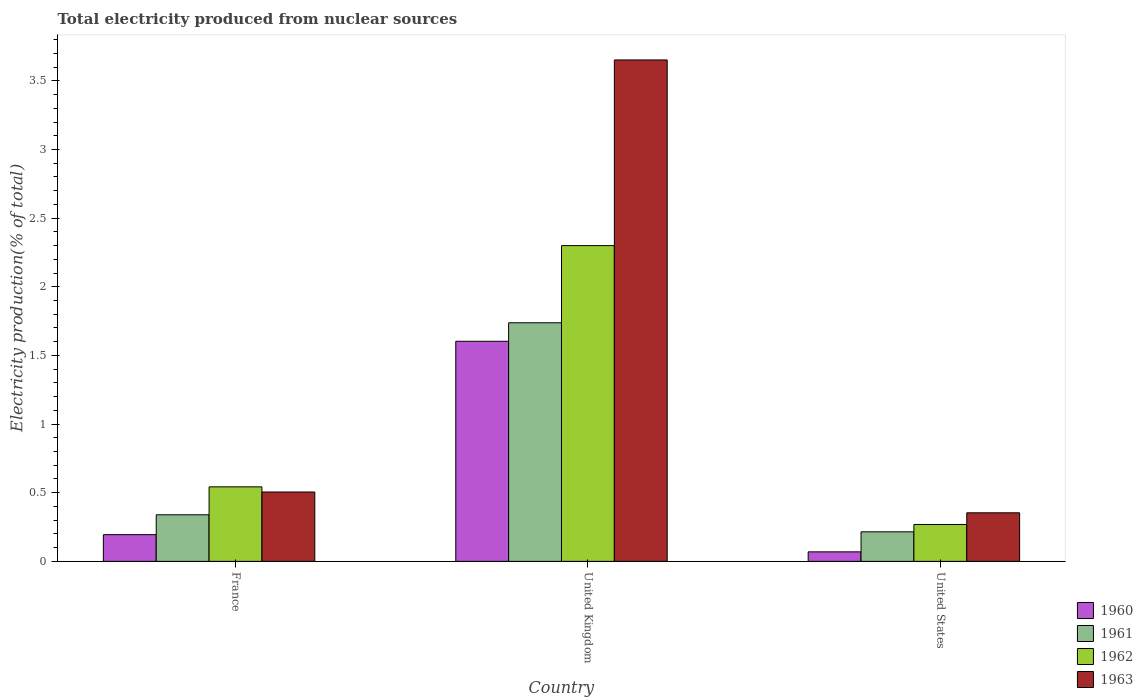How many different coloured bars are there?
Offer a very short reply. 4. How many groups of bars are there?
Your answer should be compact. 3. How many bars are there on the 3rd tick from the left?
Make the answer very short. 4. How many bars are there on the 3rd tick from the right?
Provide a succinct answer. 4. What is the label of the 3rd group of bars from the left?
Ensure brevity in your answer.  United States. In how many cases, is the number of bars for a given country not equal to the number of legend labels?
Provide a succinct answer. 0. What is the total electricity produced in 1963 in United States?
Your answer should be very brief. 0.35. Across all countries, what is the maximum total electricity produced in 1960?
Ensure brevity in your answer.  1.6. Across all countries, what is the minimum total electricity produced in 1962?
Your response must be concise. 0.27. In which country was the total electricity produced in 1962 maximum?
Ensure brevity in your answer.  United Kingdom. What is the total total electricity produced in 1961 in the graph?
Your answer should be very brief. 2.29. What is the difference between the total electricity produced in 1963 in United Kingdom and that in United States?
Your response must be concise. 3.3. What is the difference between the total electricity produced in 1962 in United Kingdom and the total electricity produced in 1961 in United States?
Keep it short and to the point. 2.08. What is the average total electricity produced in 1961 per country?
Your answer should be very brief. 0.76. What is the difference between the total electricity produced of/in 1961 and total electricity produced of/in 1960 in France?
Make the answer very short. 0.14. What is the ratio of the total electricity produced in 1960 in United Kingdom to that in United States?
Provide a short and direct response. 23.14. What is the difference between the highest and the second highest total electricity produced in 1962?
Offer a terse response. 0.27. What is the difference between the highest and the lowest total electricity produced in 1960?
Keep it short and to the point. 1.53. Is the sum of the total electricity produced in 1962 in France and United States greater than the maximum total electricity produced in 1961 across all countries?
Ensure brevity in your answer.  No. What does the 1st bar from the left in France represents?
Provide a short and direct response. 1960. Is it the case that in every country, the sum of the total electricity produced in 1962 and total electricity produced in 1960 is greater than the total electricity produced in 1963?
Ensure brevity in your answer.  No. How many bars are there?
Make the answer very short. 12. Are all the bars in the graph horizontal?
Provide a succinct answer. No. How many countries are there in the graph?
Ensure brevity in your answer.  3. What is the difference between two consecutive major ticks on the Y-axis?
Keep it short and to the point. 0.5. Are the values on the major ticks of Y-axis written in scientific E-notation?
Offer a terse response. No. Does the graph contain any zero values?
Give a very brief answer. No. Where does the legend appear in the graph?
Your answer should be compact. Bottom right. How are the legend labels stacked?
Provide a short and direct response. Vertical. What is the title of the graph?
Your answer should be very brief. Total electricity produced from nuclear sources. What is the Electricity production(% of total) in 1960 in France?
Provide a short and direct response. 0.19. What is the Electricity production(% of total) of 1961 in France?
Make the answer very short. 0.34. What is the Electricity production(% of total) in 1962 in France?
Give a very brief answer. 0.54. What is the Electricity production(% of total) in 1963 in France?
Provide a short and direct response. 0.51. What is the Electricity production(% of total) of 1960 in United Kingdom?
Offer a terse response. 1.6. What is the Electricity production(% of total) in 1961 in United Kingdom?
Provide a succinct answer. 1.74. What is the Electricity production(% of total) in 1962 in United Kingdom?
Your answer should be compact. 2.3. What is the Electricity production(% of total) in 1963 in United Kingdom?
Offer a terse response. 3.65. What is the Electricity production(% of total) of 1960 in United States?
Provide a short and direct response. 0.07. What is the Electricity production(% of total) in 1961 in United States?
Offer a terse response. 0.22. What is the Electricity production(% of total) of 1962 in United States?
Your answer should be very brief. 0.27. What is the Electricity production(% of total) in 1963 in United States?
Offer a very short reply. 0.35. Across all countries, what is the maximum Electricity production(% of total) in 1960?
Your answer should be compact. 1.6. Across all countries, what is the maximum Electricity production(% of total) of 1961?
Offer a very short reply. 1.74. Across all countries, what is the maximum Electricity production(% of total) of 1962?
Provide a short and direct response. 2.3. Across all countries, what is the maximum Electricity production(% of total) of 1963?
Give a very brief answer. 3.65. Across all countries, what is the minimum Electricity production(% of total) in 1960?
Make the answer very short. 0.07. Across all countries, what is the minimum Electricity production(% of total) of 1961?
Make the answer very short. 0.22. Across all countries, what is the minimum Electricity production(% of total) in 1962?
Your answer should be compact. 0.27. Across all countries, what is the minimum Electricity production(% of total) in 1963?
Your response must be concise. 0.35. What is the total Electricity production(% of total) of 1960 in the graph?
Your response must be concise. 1.87. What is the total Electricity production(% of total) of 1961 in the graph?
Your answer should be compact. 2.29. What is the total Electricity production(% of total) of 1962 in the graph?
Keep it short and to the point. 3.11. What is the total Electricity production(% of total) in 1963 in the graph?
Your answer should be very brief. 4.51. What is the difference between the Electricity production(% of total) in 1960 in France and that in United Kingdom?
Make the answer very short. -1.41. What is the difference between the Electricity production(% of total) of 1961 in France and that in United Kingdom?
Provide a short and direct response. -1.4. What is the difference between the Electricity production(% of total) in 1962 in France and that in United Kingdom?
Provide a succinct answer. -1.76. What is the difference between the Electricity production(% of total) of 1963 in France and that in United Kingdom?
Offer a very short reply. -3.15. What is the difference between the Electricity production(% of total) in 1960 in France and that in United States?
Make the answer very short. 0.13. What is the difference between the Electricity production(% of total) in 1961 in France and that in United States?
Offer a terse response. 0.12. What is the difference between the Electricity production(% of total) in 1962 in France and that in United States?
Your response must be concise. 0.27. What is the difference between the Electricity production(% of total) in 1963 in France and that in United States?
Ensure brevity in your answer.  0.15. What is the difference between the Electricity production(% of total) of 1960 in United Kingdom and that in United States?
Keep it short and to the point. 1.53. What is the difference between the Electricity production(% of total) of 1961 in United Kingdom and that in United States?
Your answer should be compact. 1.52. What is the difference between the Electricity production(% of total) in 1962 in United Kingdom and that in United States?
Your answer should be compact. 2.03. What is the difference between the Electricity production(% of total) in 1963 in United Kingdom and that in United States?
Your answer should be very brief. 3.3. What is the difference between the Electricity production(% of total) in 1960 in France and the Electricity production(% of total) in 1961 in United Kingdom?
Offer a terse response. -1.54. What is the difference between the Electricity production(% of total) in 1960 in France and the Electricity production(% of total) in 1962 in United Kingdom?
Give a very brief answer. -2.11. What is the difference between the Electricity production(% of total) of 1960 in France and the Electricity production(% of total) of 1963 in United Kingdom?
Provide a succinct answer. -3.46. What is the difference between the Electricity production(% of total) of 1961 in France and the Electricity production(% of total) of 1962 in United Kingdom?
Provide a succinct answer. -1.96. What is the difference between the Electricity production(% of total) of 1961 in France and the Electricity production(% of total) of 1963 in United Kingdom?
Provide a short and direct response. -3.31. What is the difference between the Electricity production(% of total) of 1962 in France and the Electricity production(% of total) of 1963 in United Kingdom?
Make the answer very short. -3.11. What is the difference between the Electricity production(% of total) in 1960 in France and the Electricity production(% of total) in 1961 in United States?
Your answer should be compact. -0.02. What is the difference between the Electricity production(% of total) in 1960 in France and the Electricity production(% of total) in 1962 in United States?
Your response must be concise. -0.07. What is the difference between the Electricity production(% of total) in 1960 in France and the Electricity production(% of total) in 1963 in United States?
Give a very brief answer. -0.16. What is the difference between the Electricity production(% of total) in 1961 in France and the Electricity production(% of total) in 1962 in United States?
Provide a short and direct response. 0.07. What is the difference between the Electricity production(% of total) of 1961 in France and the Electricity production(% of total) of 1963 in United States?
Your answer should be very brief. -0.01. What is the difference between the Electricity production(% of total) of 1962 in France and the Electricity production(% of total) of 1963 in United States?
Your response must be concise. 0.19. What is the difference between the Electricity production(% of total) of 1960 in United Kingdom and the Electricity production(% of total) of 1961 in United States?
Ensure brevity in your answer.  1.39. What is the difference between the Electricity production(% of total) of 1960 in United Kingdom and the Electricity production(% of total) of 1962 in United States?
Your answer should be very brief. 1.33. What is the difference between the Electricity production(% of total) of 1960 in United Kingdom and the Electricity production(% of total) of 1963 in United States?
Ensure brevity in your answer.  1.25. What is the difference between the Electricity production(% of total) of 1961 in United Kingdom and the Electricity production(% of total) of 1962 in United States?
Offer a very short reply. 1.47. What is the difference between the Electricity production(% of total) in 1961 in United Kingdom and the Electricity production(% of total) in 1963 in United States?
Offer a very short reply. 1.38. What is the difference between the Electricity production(% of total) in 1962 in United Kingdom and the Electricity production(% of total) in 1963 in United States?
Your answer should be very brief. 1.95. What is the average Electricity production(% of total) of 1960 per country?
Your response must be concise. 0.62. What is the average Electricity production(% of total) of 1961 per country?
Make the answer very short. 0.76. What is the average Electricity production(% of total) in 1962 per country?
Give a very brief answer. 1.04. What is the average Electricity production(% of total) in 1963 per country?
Provide a succinct answer. 1.5. What is the difference between the Electricity production(% of total) of 1960 and Electricity production(% of total) of 1961 in France?
Provide a succinct answer. -0.14. What is the difference between the Electricity production(% of total) in 1960 and Electricity production(% of total) in 1962 in France?
Keep it short and to the point. -0.35. What is the difference between the Electricity production(% of total) in 1960 and Electricity production(% of total) in 1963 in France?
Provide a succinct answer. -0.31. What is the difference between the Electricity production(% of total) of 1961 and Electricity production(% of total) of 1962 in France?
Your answer should be very brief. -0.2. What is the difference between the Electricity production(% of total) in 1961 and Electricity production(% of total) in 1963 in France?
Provide a succinct answer. -0.17. What is the difference between the Electricity production(% of total) of 1962 and Electricity production(% of total) of 1963 in France?
Offer a terse response. 0.04. What is the difference between the Electricity production(% of total) in 1960 and Electricity production(% of total) in 1961 in United Kingdom?
Keep it short and to the point. -0.13. What is the difference between the Electricity production(% of total) of 1960 and Electricity production(% of total) of 1962 in United Kingdom?
Provide a short and direct response. -0.7. What is the difference between the Electricity production(% of total) of 1960 and Electricity production(% of total) of 1963 in United Kingdom?
Your answer should be very brief. -2.05. What is the difference between the Electricity production(% of total) in 1961 and Electricity production(% of total) in 1962 in United Kingdom?
Your answer should be compact. -0.56. What is the difference between the Electricity production(% of total) of 1961 and Electricity production(% of total) of 1963 in United Kingdom?
Your response must be concise. -1.91. What is the difference between the Electricity production(% of total) of 1962 and Electricity production(% of total) of 1963 in United Kingdom?
Keep it short and to the point. -1.35. What is the difference between the Electricity production(% of total) in 1960 and Electricity production(% of total) in 1961 in United States?
Offer a terse response. -0.15. What is the difference between the Electricity production(% of total) of 1960 and Electricity production(% of total) of 1962 in United States?
Your answer should be compact. -0.2. What is the difference between the Electricity production(% of total) of 1960 and Electricity production(% of total) of 1963 in United States?
Your answer should be very brief. -0.28. What is the difference between the Electricity production(% of total) in 1961 and Electricity production(% of total) in 1962 in United States?
Make the answer very short. -0.05. What is the difference between the Electricity production(% of total) in 1961 and Electricity production(% of total) in 1963 in United States?
Your answer should be very brief. -0.14. What is the difference between the Electricity production(% of total) of 1962 and Electricity production(% of total) of 1963 in United States?
Offer a very short reply. -0.09. What is the ratio of the Electricity production(% of total) of 1960 in France to that in United Kingdom?
Give a very brief answer. 0.12. What is the ratio of the Electricity production(% of total) in 1961 in France to that in United Kingdom?
Offer a very short reply. 0.2. What is the ratio of the Electricity production(% of total) in 1962 in France to that in United Kingdom?
Your response must be concise. 0.24. What is the ratio of the Electricity production(% of total) in 1963 in France to that in United Kingdom?
Give a very brief answer. 0.14. What is the ratio of the Electricity production(% of total) of 1960 in France to that in United States?
Provide a succinct answer. 2.81. What is the ratio of the Electricity production(% of total) of 1961 in France to that in United States?
Provide a short and direct response. 1.58. What is the ratio of the Electricity production(% of total) of 1962 in France to that in United States?
Your answer should be very brief. 2.02. What is the ratio of the Electricity production(% of total) of 1963 in France to that in United States?
Provide a succinct answer. 1.43. What is the ratio of the Electricity production(% of total) in 1960 in United Kingdom to that in United States?
Provide a succinct answer. 23.14. What is the ratio of the Electricity production(% of total) in 1961 in United Kingdom to that in United States?
Your response must be concise. 8.08. What is the ratio of the Electricity production(% of total) of 1962 in United Kingdom to that in United States?
Keep it short and to the point. 8.56. What is the ratio of the Electricity production(% of total) in 1963 in United Kingdom to that in United States?
Ensure brevity in your answer.  10.32. What is the difference between the highest and the second highest Electricity production(% of total) in 1960?
Give a very brief answer. 1.41. What is the difference between the highest and the second highest Electricity production(% of total) in 1961?
Give a very brief answer. 1.4. What is the difference between the highest and the second highest Electricity production(% of total) in 1962?
Your response must be concise. 1.76. What is the difference between the highest and the second highest Electricity production(% of total) of 1963?
Make the answer very short. 3.15. What is the difference between the highest and the lowest Electricity production(% of total) in 1960?
Provide a short and direct response. 1.53. What is the difference between the highest and the lowest Electricity production(% of total) of 1961?
Ensure brevity in your answer.  1.52. What is the difference between the highest and the lowest Electricity production(% of total) of 1962?
Keep it short and to the point. 2.03. What is the difference between the highest and the lowest Electricity production(% of total) of 1963?
Ensure brevity in your answer.  3.3. 